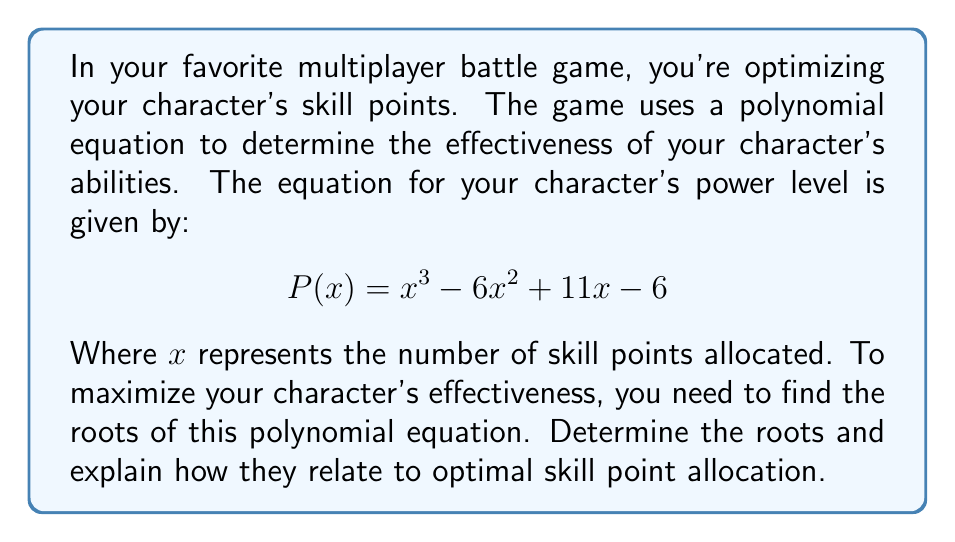Teach me how to tackle this problem. To find the roots of the polynomial equation $P(x) = x^3 - 6x^2 + 11x - 6$, we need to factor it.

Step 1: Let's start by guessing one factor. We can see that $P(1) = 1 - 6 + 11 - 6 = 0$, so $(x-1)$ is a factor.

Step 2: Divide $P(x)$ by $(x-1)$ using polynomial long division:

$x^3 - 6x^2 + 11x - 6 = (x-1)(x^2 - 5x + 6)$

Step 3: Factor the quadratic term $(x^2 - 5x + 6)$:
$(x^2 - 5x + 6) = (x-2)(x-3)$

Step 4: Combine all factors:
$P(x) = (x-1)(x-2)(x-3)$

Therefore, the roots of the polynomial are $x = 1$, $x = 2$, and $x = 3$.

In terms of the game, these roots represent critical points in skill point allocation:

1. $x = 1$: This is the minimum number of skill points needed for your character to have any power.
2. $x = 2$: This represents a balanced allocation, where your character has moderate power.
3. $x = 3$: This is the optimal allocation, maximizing your character's power level.

By understanding these roots, you can make informed decisions about how to allocate your skill points for different strategies in your multiplayer battles.
Answer: The roots of the polynomial $P(x) = x^3 - 6x^2 + 11x - 6$ are $x = 1$, $x = 2$, and $x = 3$. 